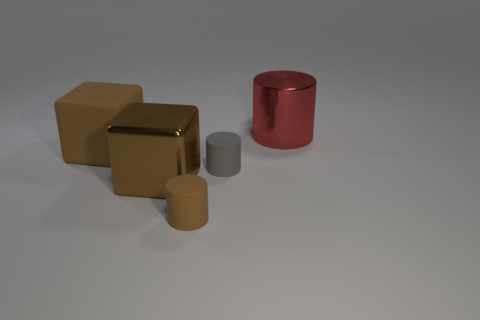Add 1 big brown metal blocks. How many objects exist? 6 Subtract all blocks. How many objects are left? 3 Add 3 large metallic cubes. How many large metallic cubes exist? 4 Subtract 1 gray cylinders. How many objects are left? 4 Subtract all tiny red objects. Subtract all small brown matte objects. How many objects are left? 4 Add 4 red metal cylinders. How many red metal cylinders are left? 5 